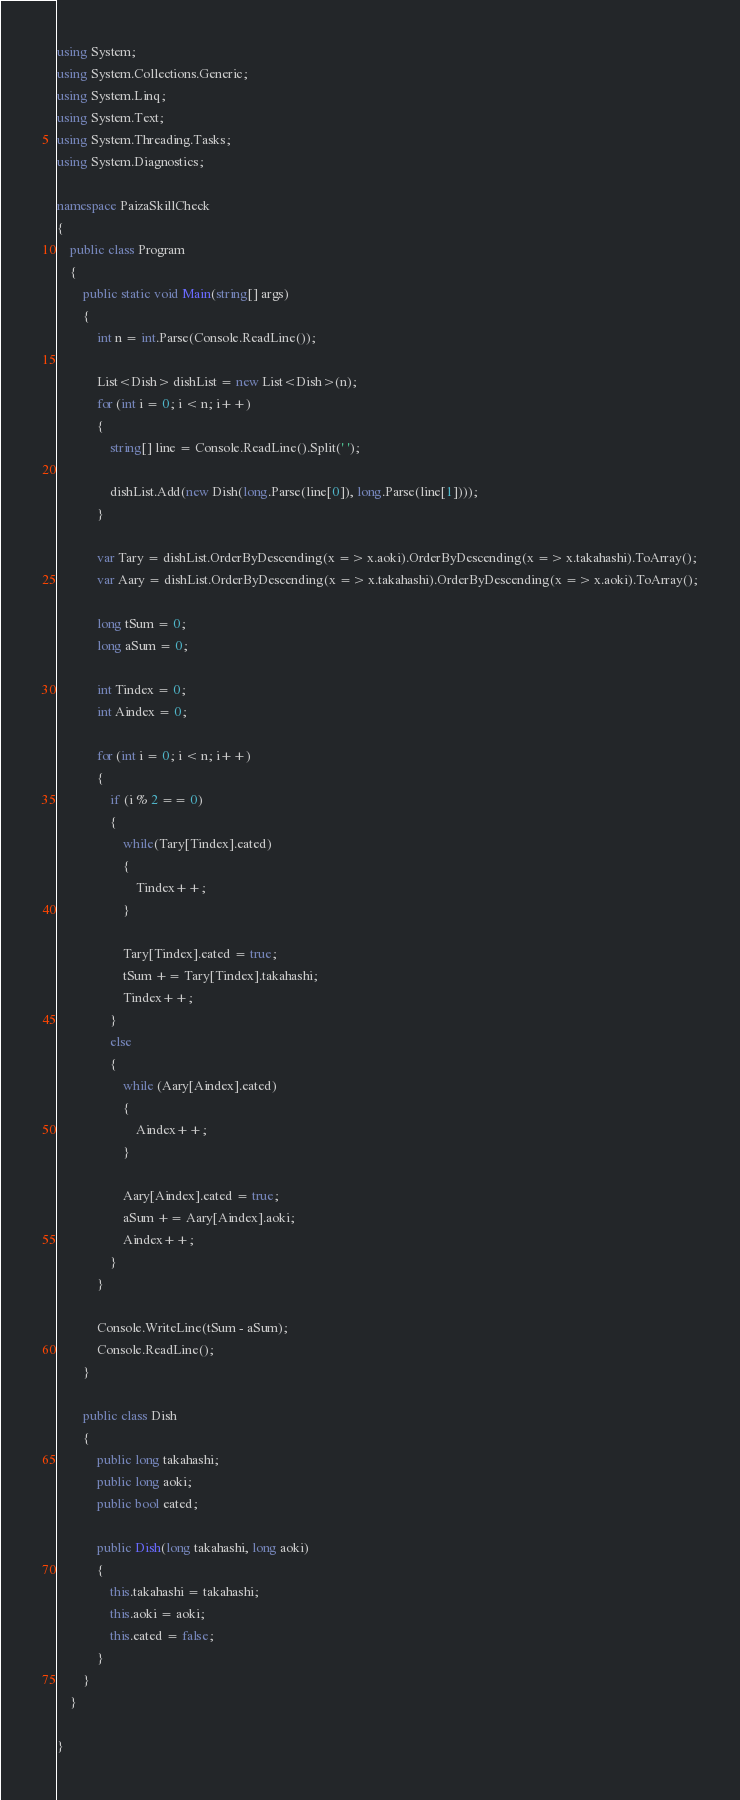<code> <loc_0><loc_0><loc_500><loc_500><_C#_>using System;
using System.Collections.Generic;
using System.Linq;
using System.Text;
using System.Threading.Tasks;
using System.Diagnostics;

namespace PaizaSkillCheck
{
    public class Program
    {
        public static void Main(string[] args)
        {
            int n = int.Parse(Console.ReadLine());

            List<Dish> dishList = new List<Dish>(n);
            for (int i = 0; i < n; i++)
            {
                string[] line = Console.ReadLine().Split(' ');

                dishList.Add(new Dish(long.Parse(line[0]), long.Parse(line[1])));
            }

            var Tary = dishList.OrderByDescending(x => x.aoki).OrderByDescending(x => x.takahashi).ToArray();
            var Aary = dishList.OrderByDescending(x => x.takahashi).OrderByDescending(x => x.aoki).ToArray();

            long tSum = 0;
            long aSum = 0;

            int Tindex = 0;
            int Aindex = 0;

            for (int i = 0; i < n; i++)
            {
                if (i % 2 == 0)
                {
                    while(Tary[Tindex].eated)
                    {
                        Tindex++;
                    }

                    Tary[Tindex].eated = true;
                    tSum += Tary[Tindex].takahashi;
                    Tindex++;
                }
                else
                {
                    while (Aary[Aindex].eated)
                    {
                        Aindex++;
                    }

                    Aary[Aindex].eated = true;
                    aSum += Aary[Aindex].aoki;
                    Aindex++;
                }
            }

            Console.WriteLine(tSum - aSum);
            Console.ReadLine();
        }

        public class Dish
        {
            public long takahashi;
            public long aoki;
            public bool eated;

            public Dish(long takahashi, long aoki)
            {
                this.takahashi = takahashi;
                this.aoki = aoki;
                this.eated = false;
            }
        }
    }

}
</code> 